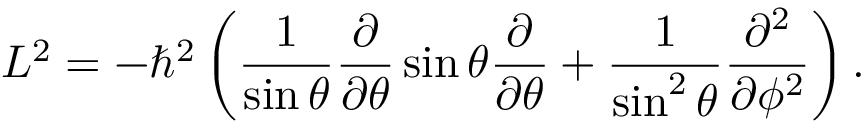Convert formula to latex. <formula><loc_0><loc_0><loc_500><loc_500>L ^ { 2 } = - \hbar { ^ } { 2 } \left ( \frac { 1 } { \sin \theta } \frac { \partial } { \partial \theta } \sin \theta \frac { \partial } { \partial \theta } + \frac { 1 } { \sin ^ { 2 } \theta } \frac { \partial ^ { 2 } } { \partial \phi ^ { 2 } } \right ) .</formula> 